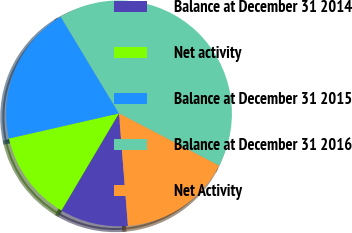Convert chart to OTSL. <chart><loc_0><loc_0><loc_500><loc_500><pie_chart><fcel>Balance at December 31 2014<fcel>Net activity<fcel>Balance at December 31 2015<fcel>Balance at December 31 2016<fcel>Net Activity<nl><fcel>9.77%<fcel>12.92%<fcel>19.94%<fcel>41.3%<fcel>16.07%<nl></chart> 